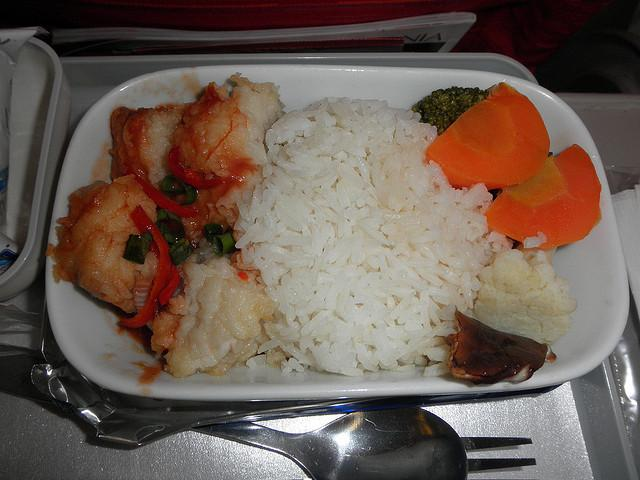On which plant does the vegetable that is reddest here grow? Please explain your reasoning. pepper. There is only one red vegetable. chicken is eaten with peppers. 